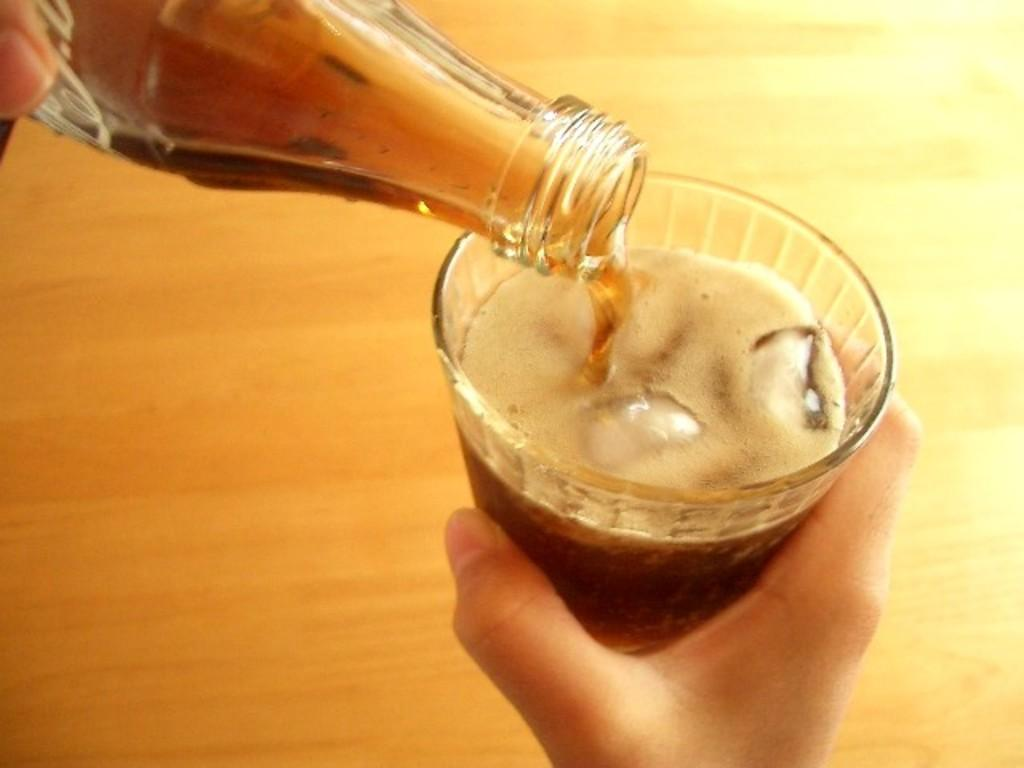What body parts are visible in the image? There are a person's hands in the image. What objects is the person holding? The person is holding a bottle and a glass. What is inside the glass? There is liquid in the glass. What can be seen in the background of the image? There is a colorful surface in the background of the image. What type of locket is hanging from the person's neck in the image? There is no locket visible in the image; only the person's hands, a bottle, a glass, and a colorful background are present. 